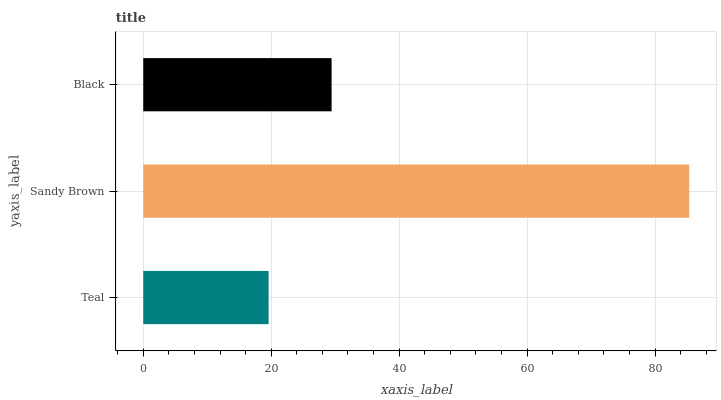Is Teal the minimum?
Answer yes or no. Yes. Is Sandy Brown the maximum?
Answer yes or no. Yes. Is Black the minimum?
Answer yes or no. No. Is Black the maximum?
Answer yes or no. No. Is Sandy Brown greater than Black?
Answer yes or no. Yes. Is Black less than Sandy Brown?
Answer yes or no. Yes. Is Black greater than Sandy Brown?
Answer yes or no. No. Is Sandy Brown less than Black?
Answer yes or no. No. Is Black the high median?
Answer yes or no. Yes. Is Black the low median?
Answer yes or no. Yes. Is Teal the high median?
Answer yes or no. No. Is Teal the low median?
Answer yes or no. No. 